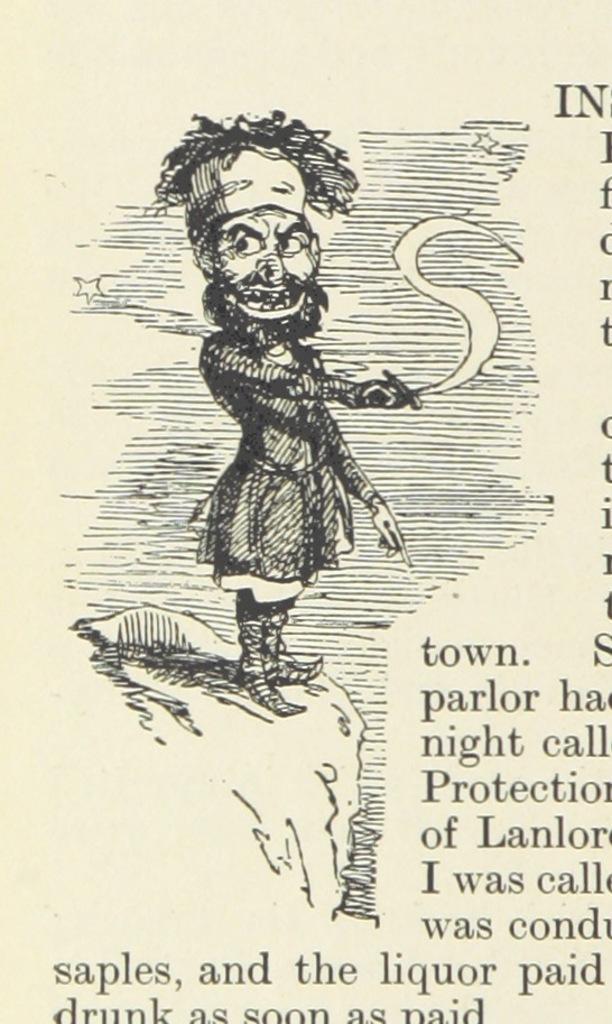In one or two sentences, can you explain what this image depicts? In the image it looks like a page, there is some animated image and beside that there is some text. 